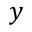<formula> <loc_0><loc_0><loc_500><loc_500>y</formula> 